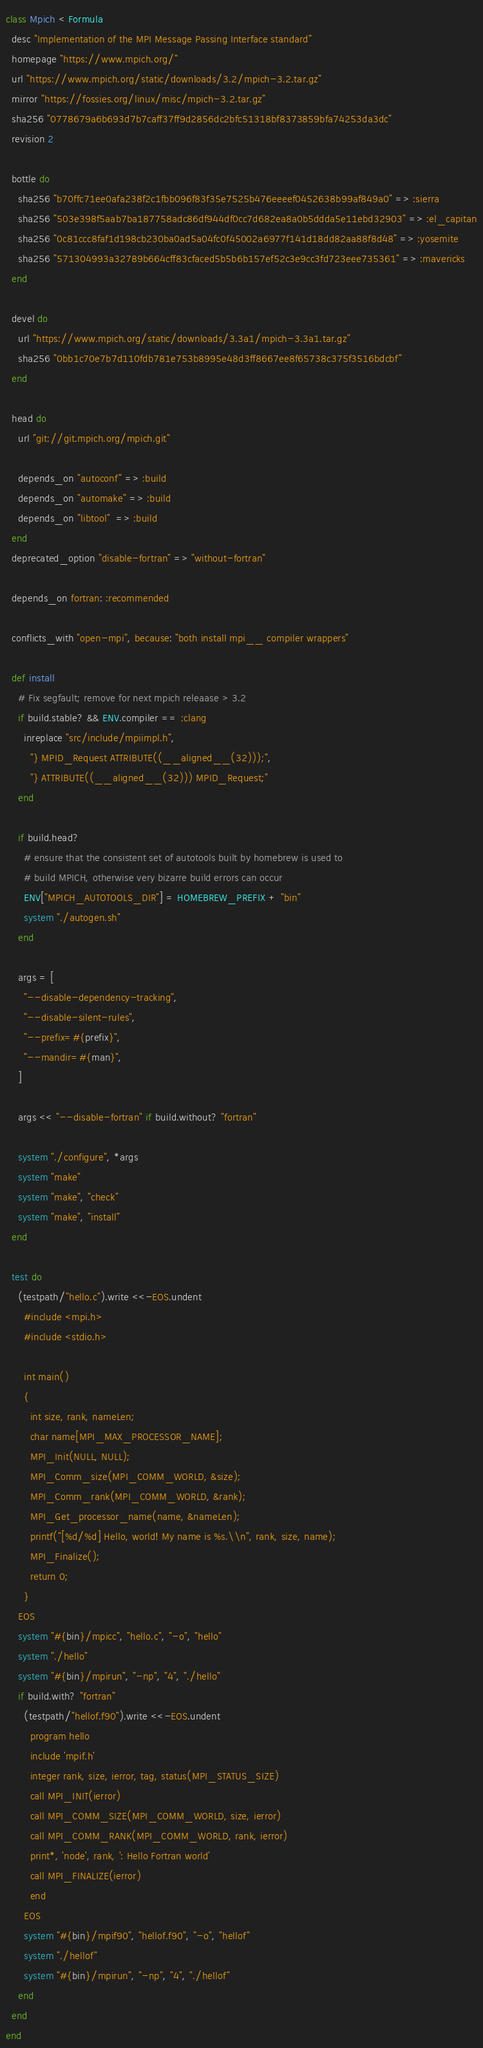Convert code to text. <code><loc_0><loc_0><loc_500><loc_500><_Ruby_>class Mpich < Formula
  desc "Implementation of the MPI Message Passing Interface standard"
  homepage "https://www.mpich.org/"
  url "https://www.mpich.org/static/downloads/3.2/mpich-3.2.tar.gz"
  mirror "https://fossies.org/linux/misc/mpich-3.2.tar.gz"
  sha256 "0778679a6b693d7b7caff37ff9d2856dc2bfc51318bf8373859bfa74253da3dc"
  revision 2

  bottle do
    sha256 "b70ffc71ee0afa238f2c1fbb096f83f35e7525b476eeeef0452638b99af849a0" => :sierra
    sha256 "503e398f5aab7ba187758adc86df944df0cc7d682ea8a0b5ddda5e11ebd32903" => :el_capitan
    sha256 "0c81ccc8faf1d198cb230ba0ad5a04fc0f45002a6977f141d18dd82aa88f8d48" => :yosemite
    sha256 "571304993a32789b664cff83cfaced5b5b6b157ef52c3e9cc3fd723eee735361" => :mavericks
  end

  devel do
    url "https://www.mpich.org/static/downloads/3.3a1/mpich-3.3a1.tar.gz"
    sha256 "0bb1c70e7b7d110fdb781e753b8995e48d3ff8667ee8f65738c375f3516bdcbf"
  end

  head do
    url "git://git.mpich.org/mpich.git"

    depends_on "autoconf" => :build
    depends_on "automake" => :build
    depends_on "libtool"  => :build
  end
  deprecated_option "disable-fortran" => "without-fortran"

  depends_on fortran: :recommended

  conflicts_with "open-mpi", because: "both install mpi__ compiler wrappers"

  def install
    # Fix segfault; remove for next mpich releaase > 3.2
    if build.stable? && ENV.compiler == :clang
      inreplace "src/include/mpiimpl.h",
        "} MPID_Request ATTRIBUTE((__aligned__(32)));",
        "} ATTRIBUTE((__aligned__(32))) MPID_Request;"
    end

    if build.head?
      # ensure that the consistent set of autotools built by homebrew is used to
      # build MPICH, otherwise very bizarre build errors can occur
      ENV["MPICH_AUTOTOOLS_DIR"] = HOMEBREW_PREFIX + "bin"
      system "./autogen.sh"
    end

    args = [
      "--disable-dependency-tracking",
      "--disable-silent-rules",
      "--prefix=#{prefix}",
      "--mandir=#{man}",
    ]

    args << "--disable-fortran" if build.without? "fortran"

    system "./configure", *args
    system "make"
    system "make", "check"
    system "make", "install"
  end

  test do
    (testpath/"hello.c").write <<-EOS.undent
      #include <mpi.h>
      #include <stdio.h>

      int main()
      {
        int size, rank, nameLen;
        char name[MPI_MAX_PROCESSOR_NAME];
        MPI_Init(NULL, NULL);
        MPI_Comm_size(MPI_COMM_WORLD, &size);
        MPI_Comm_rank(MPI_COMM_WORLD, &rank);
        MPI_Get_processor_name(name, &nameLen);
        printf("[%d/%d] Hello, world! My name is %s.\\n", rank, size, name);
        MPI_Finalize();
        return 0;
      }
    EOS
    system "#{bin}/mpicc", "hello.c", "-o", "hello"
    system "./hello"
    system "#{bin}/mpirun", "-np", "4", "./hello"
    if build.with? "fortran"
      (testpath/"hellof.f90").write <<-EOS.undent
        program hello
        include 'mpif.h'
        integer rank, size, ierror, tag, status(MPI_STATUS_SIZE)
        call MPI_INIT(ierror)
        call MPI_COMM_SIZE(MPI_COMM_WORLD, size, ierror)
        call MPI_COMM_RANK(MPI_COMM_WORLD, rank, ierror)
        print*, 'node', rank, ': Hello Fortran world'
        call MPI_FINALIZE(ierror)
        end
      EOS
      system "#{bin}/mpif90", "hellof.f90", "-o", "hellof"
      system "./hellof"
      system "#{bin}/mpirun", "-np", "4", "./hellof"
    end
  end
end
</code> 